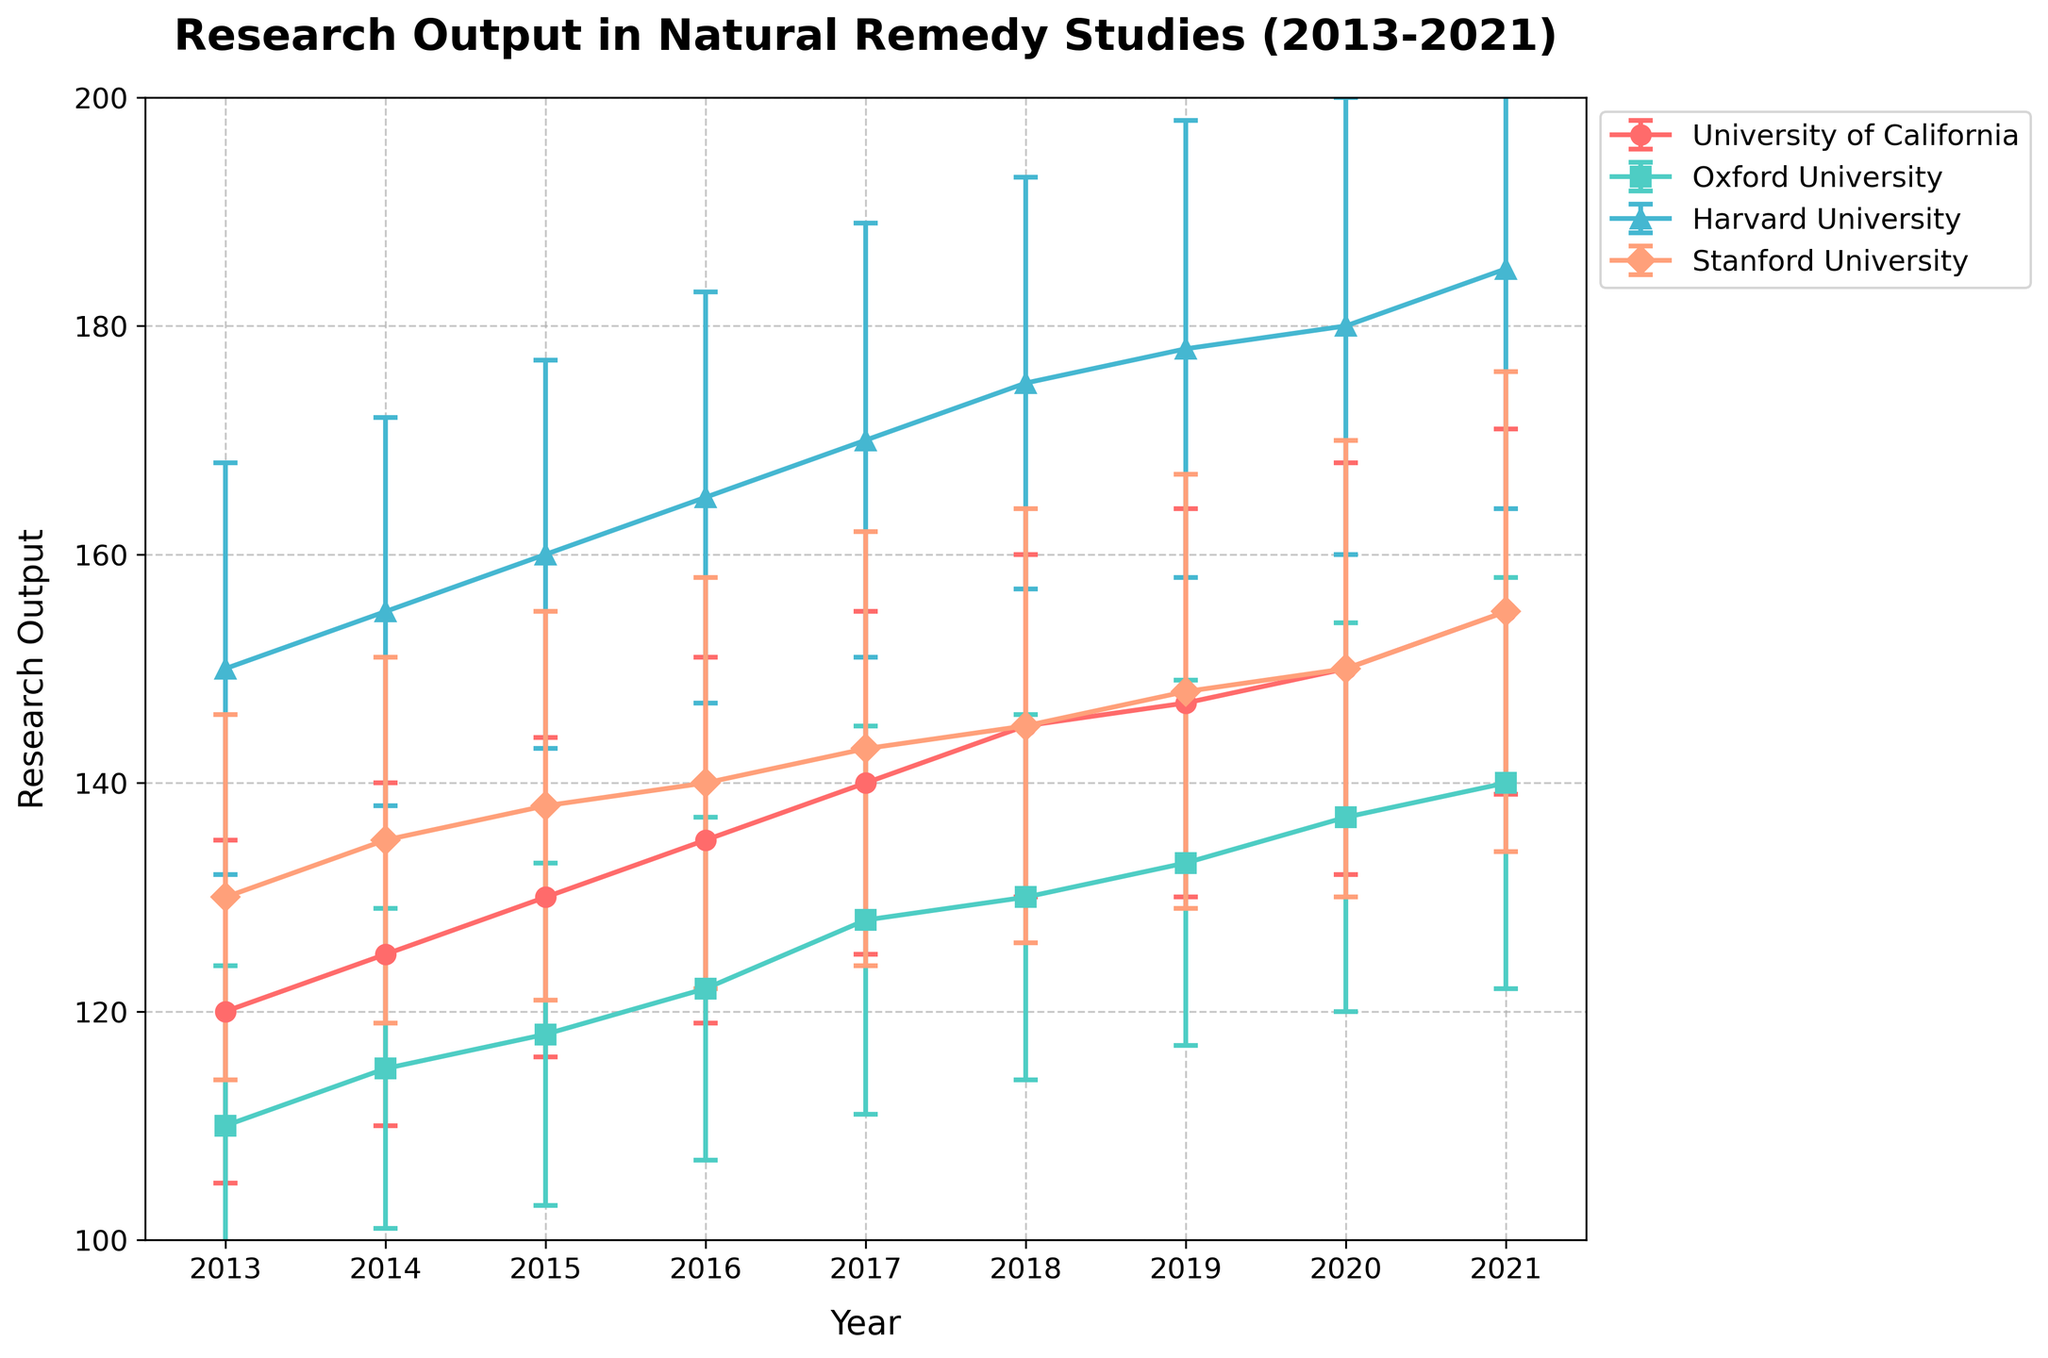How many institutions are represented in the figure? Identify unique institutions by looking at the labels in the legend. The legend shows four institutions: University of California, Oxford University, Harvard University, and Stanford University.
Answer: 4 What is the y-axis label? Read the y-axis label directly from the plot. The y-axis is labeled "Research Output."
Answer: Research Output Which institution shows the highest research output in 2021? Look at the data points for the year 2021 and compare the y-values for each institution. Harvard University shows the highest point at 185.
Answer: Harvard University What trends can be observed in the research output of Stanford University from 2013 to 2021? Follow the line corresponding to Stanford University from 2013 to 2021. The output generally increases from 130 to 155.
Answer: Increasing from 130 to 155 Compare the changes in research output from 2019 to 2020 for Harvard University and Stanford University. Which institution shows a greater increase? Calculate the difference for each institution from 2019 to 2020. Harvard University: 180 - 178 = 2, Stanford University: 150 -148 = 2. Both show an increase of 2 units.
Answer: Both show an increase of 2 What year did the University of California experience the highest error margin in its research output? Check the length of the error bars across the years for University of California. The error bar is longest in 2020.
Answer: 2020 How does the research output in 2017 compare between Oxford University and Harvard University? Locate the points for 2017 for both institutions and compare their y-values. Oxford University has a research output of 128, and Harvard University has 170.
Answer: Harvard University has higher output Which institution had the steadiest increase in research output over the observed period? Examine the lines for each institution for consistent slope from 2013 to 2021. University of California has a gradually increasing, steady trend.
Answer: University of California What is the range of research output for Oxford University from 2013 to 2021? Identify the highest and lowest points for Oxford University from 2013 to 2021. The output ranges from 110 to 140.
Answer: 110 to 140 How did the error margin change for Harvard University from 2013 to 2021? Observe the lengths of the error bars for Harvard University from 2013 to 2021. The error margin increases from 18 to 21.
Answer: Increased from 18 to 21 